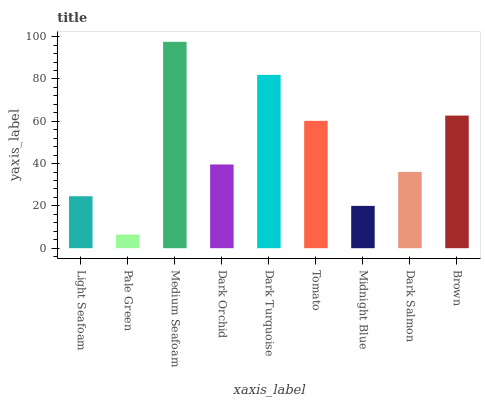Is Medium Seafoam the minimum?
Answer yes or no. No. Is Pale Green the maximum?
Answer yes or no. No. Is Medium Seafoam greater than Pale Green?
Answer yes or no. Yes. Is Pale Green less than Medium Seafoam?
Answer yes or no. Yes. Is Pale Green greater than Medium Seafoam?
Answer yes or no. No. Is Medium Seafoam less than Pale Green?
Answer yes or no. No. Is Dark Orchid the high median?
Answer yes or no. Yes. Is Dark Orchid the low median?
Answer yes or no. Yes. Is Brown the high median?
Answer yes or no. No. Is Dark Turquoise the low median?
Answer yes or no. No. 